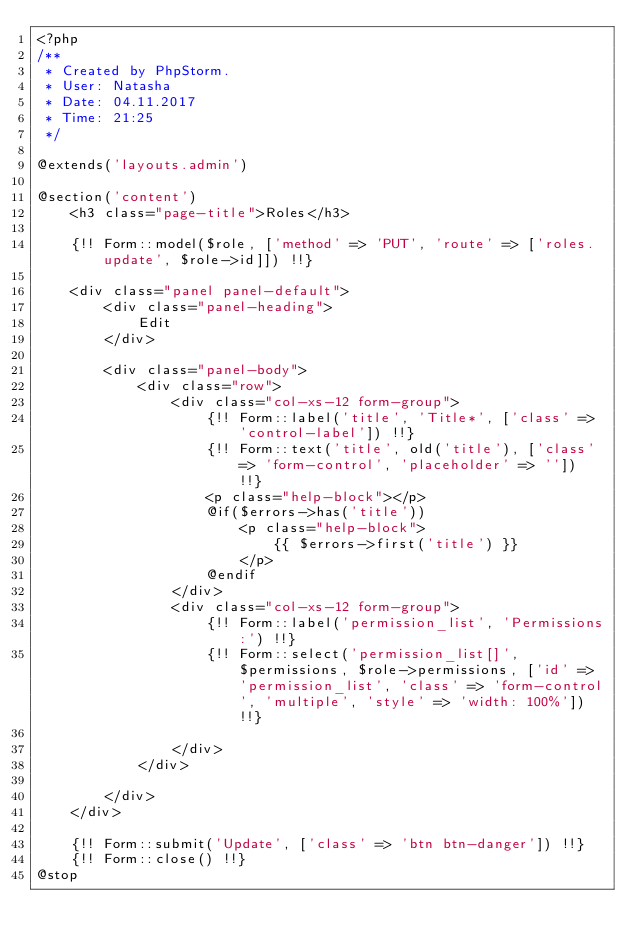Convert code to text. <code><loc_0><loc_0><loc_500><loc_500><_PHP_><?php
/**
 * Created by PhpStorm.
 * User: Natasha
 * Date: 04.11.2017
 * Time: 21:25
 */

@extends('layouts.admin')

@section('content')
    <h3 class="page-title">Roles</h3>

    {!! Form::model($role, ['method' => 'PUT', 'route' => ['roles.update', $role->id]]) !!}

    <div class="panel panel-default">
        <div class="panel-heading">
            Edit
        </div>

        <div class="panel-body">
            <div class="row">
                <div class="col-xs-12 form-group">
                    {!! Form::label('title', 'Title*', ['class' => 'control-label']) !!}
                    {!! Form::text('title', old('title'), ['class' => 'form-control', 'placeholder' => '']) !!}
                    <p class="help-block"></p>
                    @if($errors->has('title'))
                        <p class="help-block">
                            {{ $errors->first('title') }}
                        </p>
                    @endif
                </div>
                <div class="col-xs-12 form-group">
                    {!! Form::label('permission_list', 'Permissions:') !!}
                    {!! Form::select('permission_list[]', $permissions, $role->permissions, ['id' => 'permission_list', 'class' => 'form-control', 'multiple', 'style' => 'width: 100%']) !!}

                </div>
            </div>

        </div>
    </div>

    {!! Form::submit('Update', ['class' => 'btn btn-danger']) !!}
    {!! Form::close() !!}
@stop</code> 